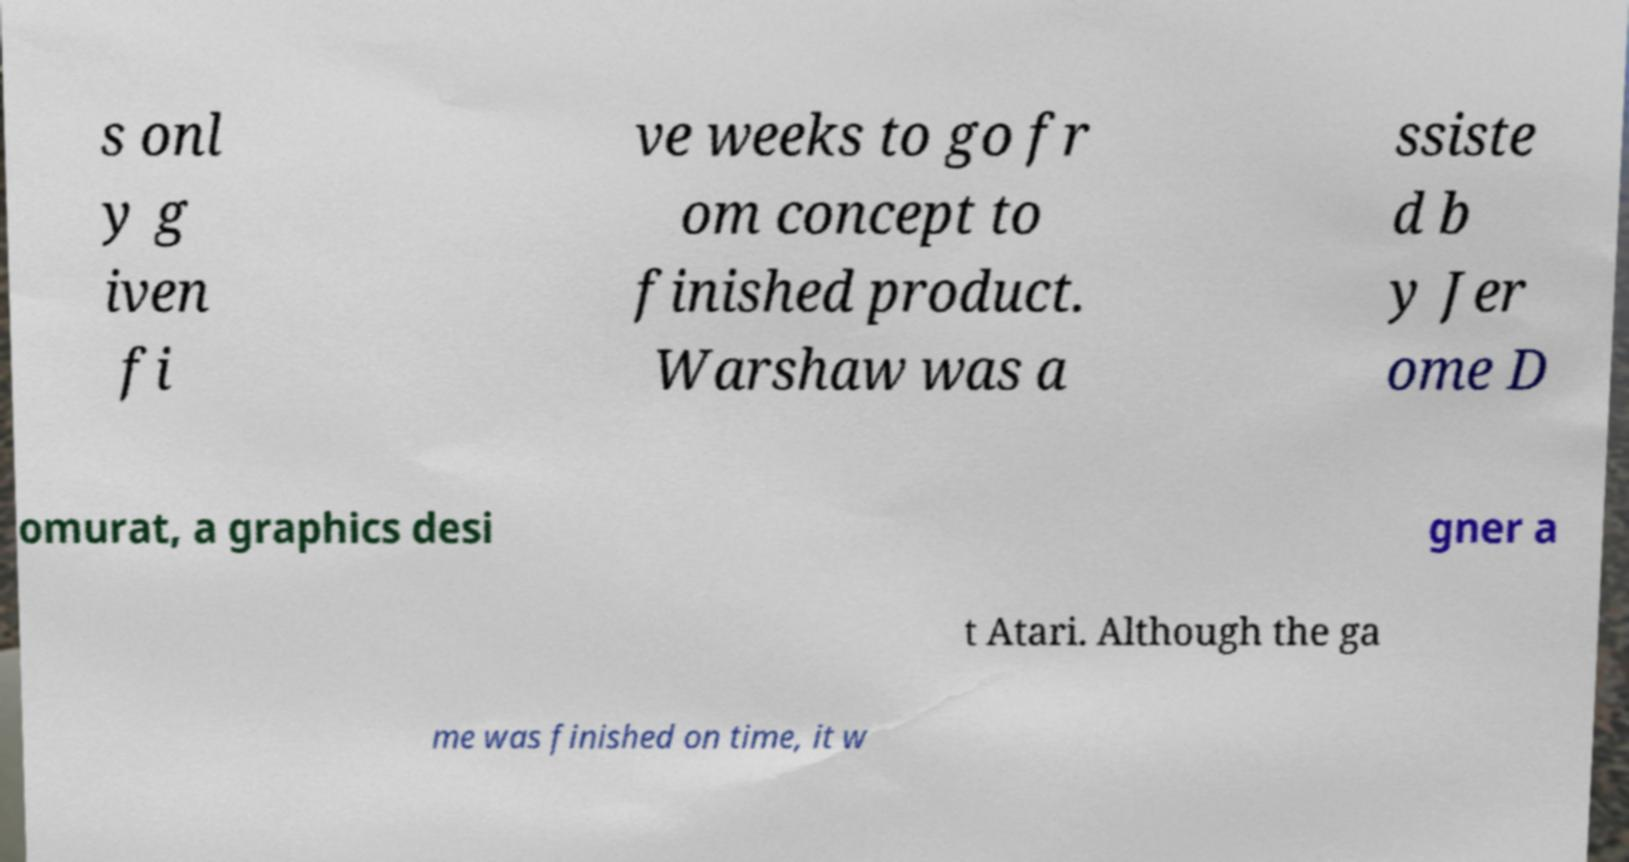I need the written content from this picture converted into text. Can you do that? s onl y g iven fi ve weeks to go fr om concept to finished product. Warshaw was a ssiste d b y Jer ome D omurat, a graphics desi gner a t Atari. Although the ga me was finished on time, it w 